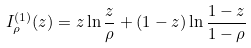Convert formula to latex. <formula><loc_0><loc_0><loc_500><loc_500>I _ { \rho } ^ { ( 1 ) } ( z ) = z \ln \frac { z } { \rho } + ( 1 - z ) \ln \frac { 1 - z } { 1 - \rho }</formula> 